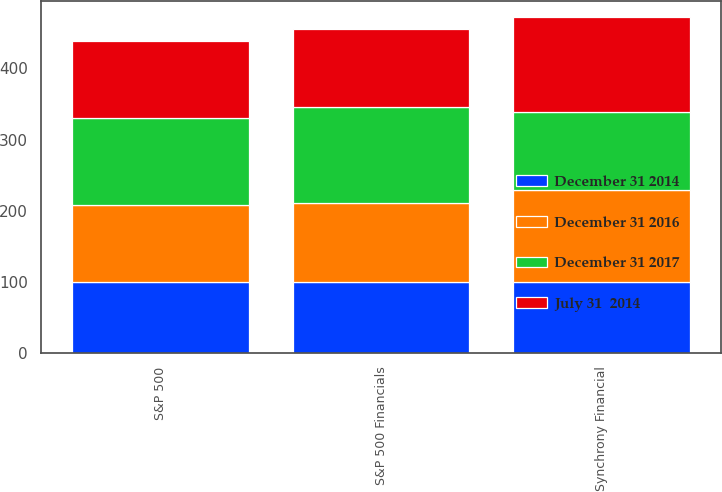Convert chart. <chart><loc_0><loc_0><loc_500><loc_500><stacked_bar_chart><ecel><fcel>Synchrony Financial<fcel>S&P 500<fcel>S&P 500 Financials<nl><fcel>December 31 2014<fcel>100<fcel>100<fcel>100<nl><fcel>December 31 2016<fcel>129.35<fcel>107.6<fcel>111.35<nl><fcel>July 31  2014<fcel>132.22<fcel>109.09<fcel>109.65<nl><fcel>December 31 2017<fcel>109.65<fcel>122.14<fcel>134.65<nl></chart> 